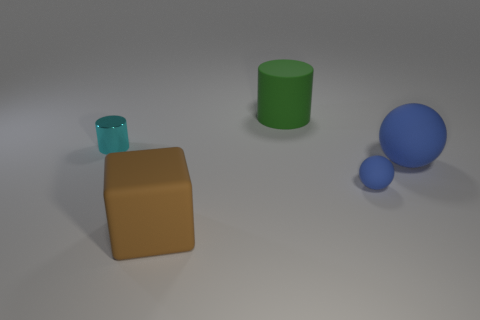How many matte objects are green objects or blue objects? In the image, there are two matte objects that qualify as green or blue, one being the green cylinder and the other being the small blue sphere. 